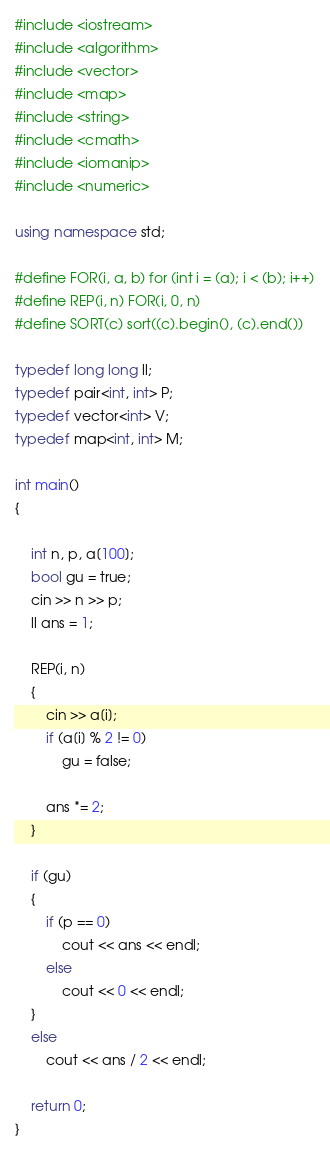Convert code to text. <code><loc_0><loc_0><loc_500><loc_500><_C++_>#include <iostream>
#include <algorithm>
#include <vector>
#include <map>
#include <string>
#include <cmath>
#include <iomanip>
#include <numeric>

using namespace std;

#define FOR(i, a, b) for (int i = (a); i < (b); i++)
#define REP(i, n) FOR(i, 0, n)
#define SORT(c) sort((c).begin(), (c).end())

typedef long long ll;
typedef pair<int, int> P;
typedef vector<int> V;
typedef map<int, int> M;

int main()
{

    int n, p, a[100];
    bool gu = true;
    cin >> n >> p;
    ll ans = 1;

    REP(i, n)
    {
        cin >> a[i];
        if (a[i] % 2 != 0)
            gu = false;

        ans *= 2;
    }

    if (gu)
    {
        if (p == 0)
            cout << ans << endl;
        else
            cout << 0 << endl;
    }
    else
        cout << ans / 2 << endl;

    return 0;
}</code> 